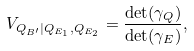<formula> <loc_0><loc_0><loc_500><loc_500>V _ { Q _ { B ^ { \prime } } | Q _ { E _ { 1 } } , Q _ { E _ { 2 } } } = \frac { \det ( \gamma _ { Q } ) } { \det ( \gamma _ { E } ) } ,</formula> 